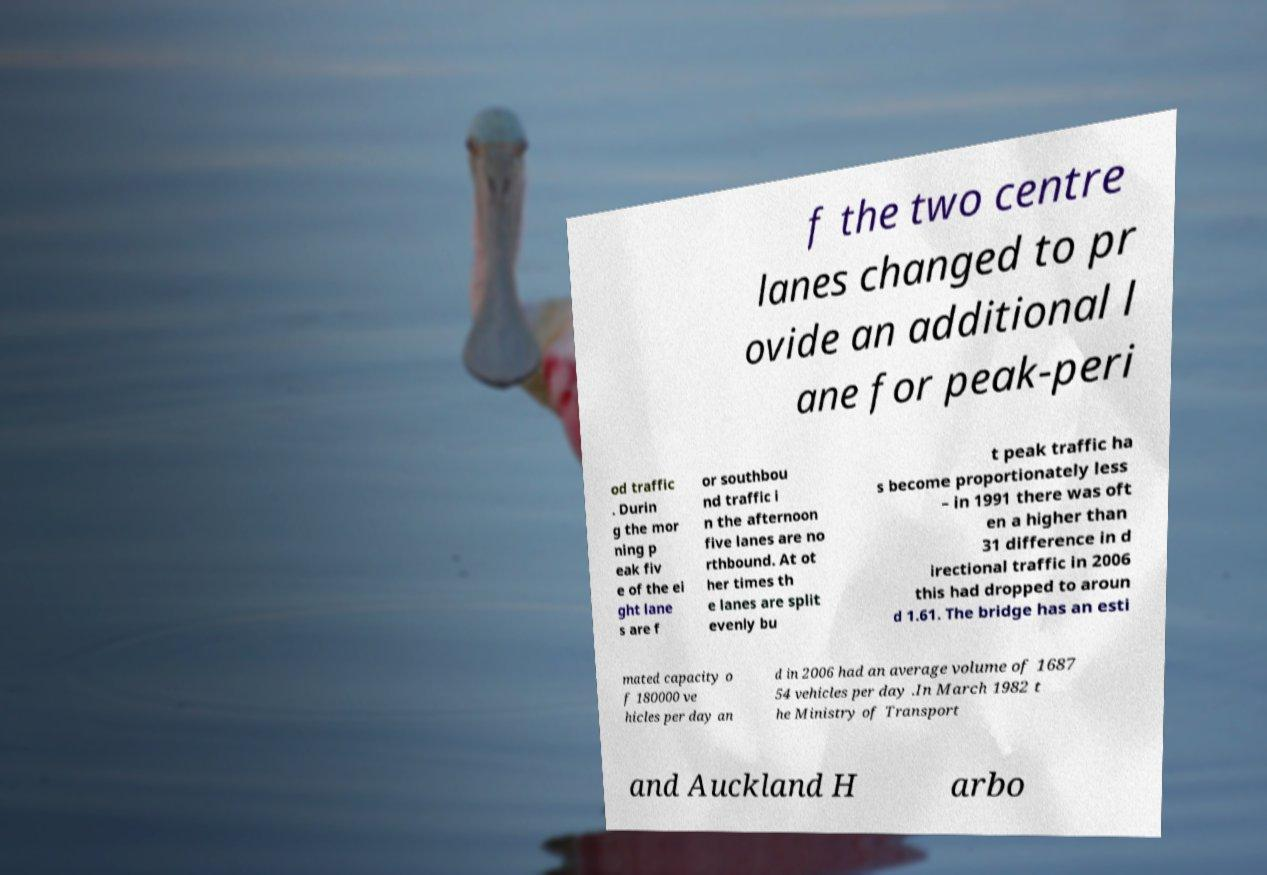Please read and relay the text visible in this image. What does it say? f the two centre lanes changed to pr ovide an additional l ane for peak-peri od traffic . Durin g the mor ning p eak fiv e of the ei ght lane s are f or southbou nd traffic i n the afternoon five lanes are no rthbound. At ot her times th e lanes are split evenly bu t peak traffic ha s become proportionately less – in 1991 there was oft en a higher than 31 difference in d irectional traffic in 2006 this had dropped to aroun d 1.61. The bridge has an esti mated capacity o f 180000 ve hicles per day an d in 2006 had an average volume of 1687 54 vehicles per day .In March 1982 t he Ministry of Transport and Auckland H arbo 